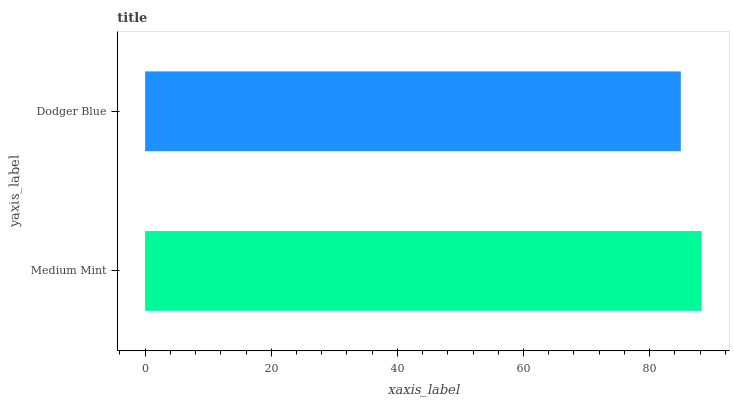Is Dodger Blue the minimum?
Answer yes or no. Yes. Is Medium Mint the maximum?
Answer yes or no. Yes. Is Dodger Blue the maximum?
Answer yes or no. No. Is Medium Mint greater than Dodger Blue?
Answer yes or no. Yes. Is Dodger Blue less than Medium Mint?
Answer yes or no. Yes. Is Dodger Blue greater than Medium Mint?
Answer yes or no. No. Is Medium Mint less than Dodger Blue?
Answer yes or no. No. Is Medium Mint the high median?
Answer yes or no. Yes. Is Dodger Blue the low median?
Answer yes or no. Yes. Is Dodger Blue the high median?
Answer yes or no. No. Is Medium Mint the low median?
Answer yes or no. No. 